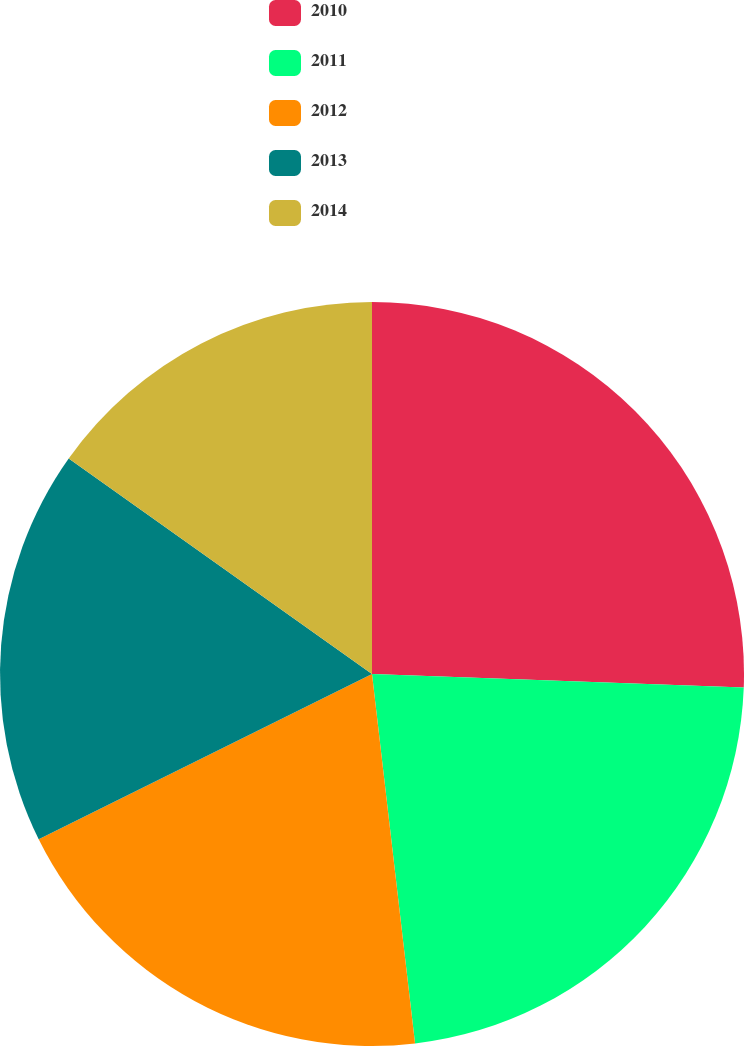Convert chart. <chart><loc_0><loc_0><loc_500><loc_500><pie_chart><fcel>2010<fcel>2011<fcel>2012<fcel>2013<fcel>2014<nl><fcel>25.58%<fcel>22.57%<fcel>19.52%<fcel>17.15%<fcel>15.17%<nl></chart> 